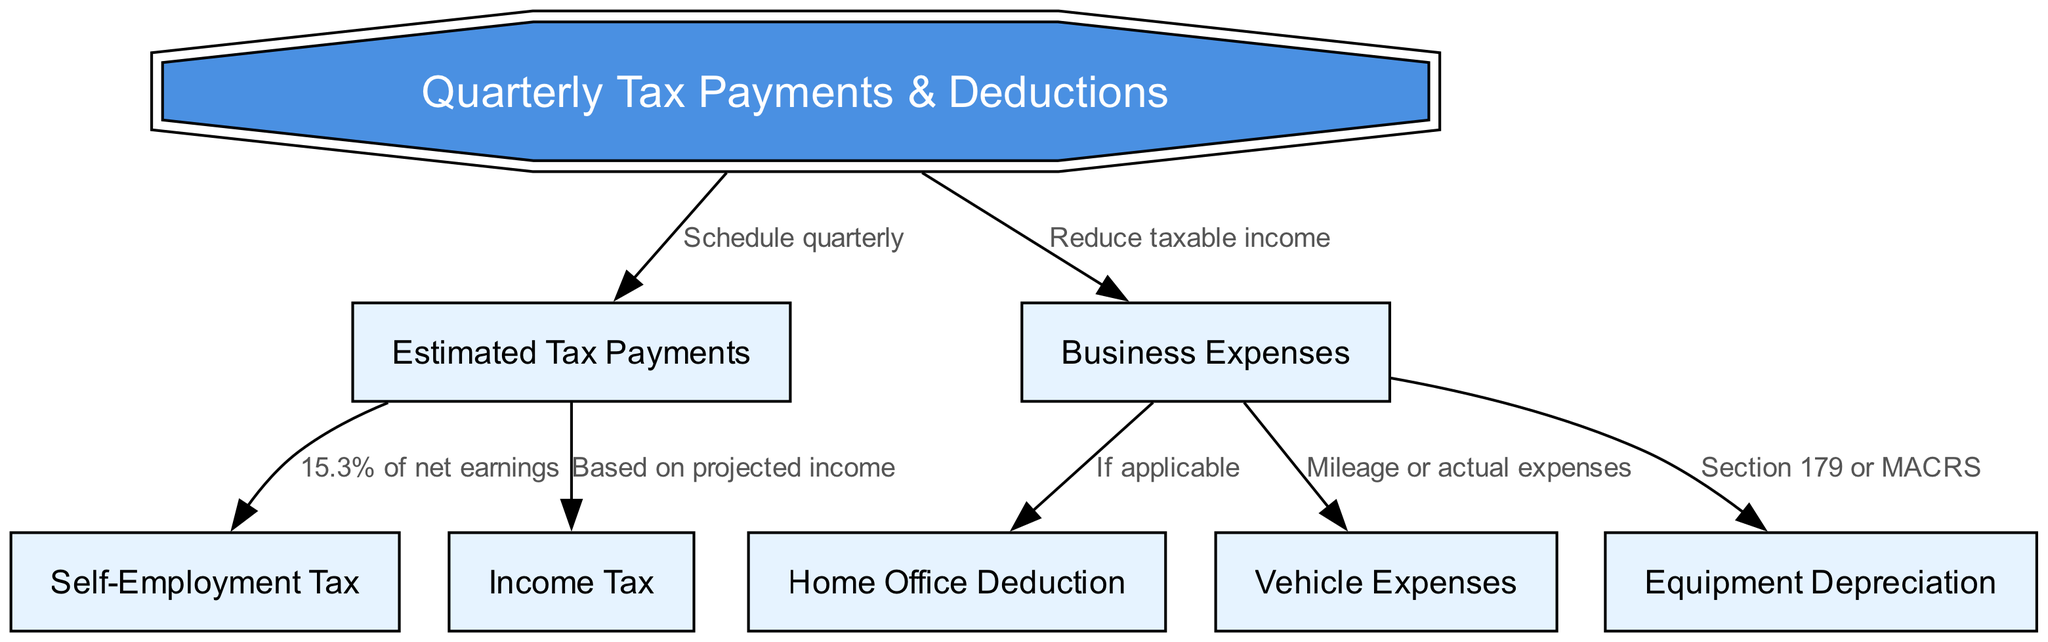What are the main components of the diagram? The diagram consists of one main component, which is "Quarterly Tax Payments & Deductions," and six other nodes: "Estimated Tax Payments," "Self-Employment Tax," "Income Tax," "Business Expenses," "Home Office Deduction," "Vehicle Expenses," and "Equipment Depreciation."
Answer: One main component and six other nodes How many connections are there in the diagram? By counting the connections listed in the data, there are a total of six connections indicating the flow between different nodes.
Answer: Six connections What is the label on the edge leading from Estimated Tax Payments to Self-Employment Tax? The label on the edge leading from "Estimated Tax Payments" to "Self-Employment Tax" is "15.3% of net earnings."
Answer: 15.3% of net earnings What type of expenses can reduce taxable income? The diagram shows that "Business Expenses" can reduce taxable income.
Answer: Business Expenses For which deduction is it mentioned "If applicable"? The diagram specifies that the "Home Office Deduction" applies only "If applicable."
Answer: Home Office Deduction What percentage is used for Self-Employment Tax calculations? According to the diagram, the percentage used for calculating Self-Employment Tax is 15.3%.
Answer: 15.3% What deduction relates to mileage or actual expenses? The diagram indicates that "Vehicle Expenses" can relate to mileage or actual expenses.
Answer: Vehicle Expenses What is the relationship between Business Expenses and Equipment Depreciation? The relationship is shown as a connection from "Business Expenses" to "Equipment Depreciation," labeled with "Section 179 or MACRS," indicating methods of depreciation.
Answer: Equipment Depreciation 